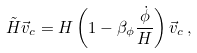Convert formula to latex. <formula><loc_0><loc_0><loc_500><loc_500>\tilde { H } \vec { v } _ { c } = H \left ( 1 - \beta _ { \phi } \frac { \dot { \phi } } { H } \right ) \vec { v } _ { c } \, ,</formula> 